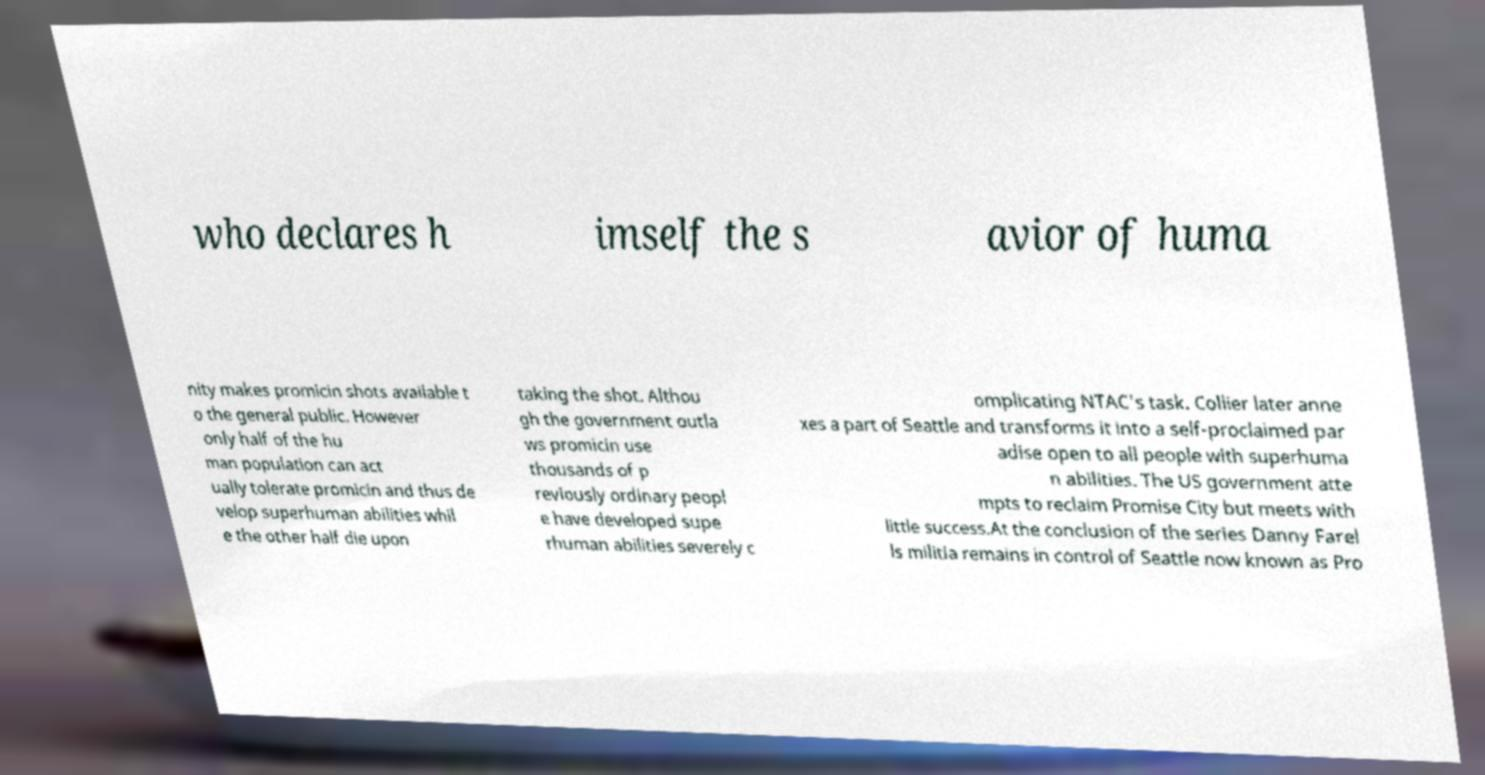There's text embedded in this image that I need extracted. Can you transcribe it verbatim? who declares h imself the s avior of huma nity makes promicin shots available t o the general public. However only half of the hu man population can act ually tolerate promicin and thus de velop superhuman abilities whil e the other half die upon taking the shot. Althou gh the government outla ws promicin use thousands of p reviously ordinary peopl e have developed supe rhuman abilities severely c omplicating NTAC's task. Collier later anne xes a part of Seattle and transforms it into a self-proclaimed par adise open to all people with superhuma n abilities. The US government atte mpts to reclaim Promise City but meets with little success.At the conclusion of the series Danny Farel ls militia remains in control of Seattle now known as Pro 